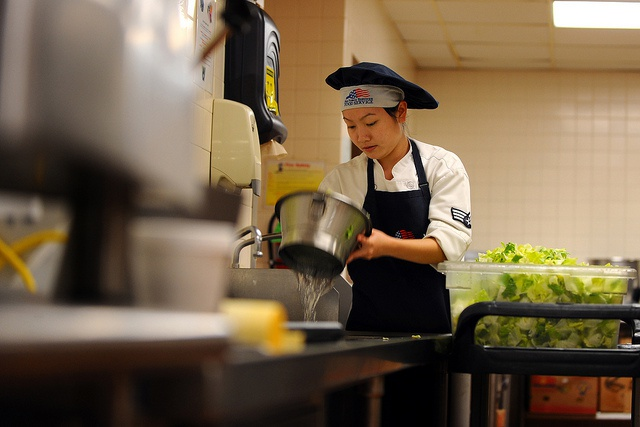Describe the objects in this image and their specific colors. I can see people in black, ivory, brown, and tan tones, cup in black, tan, and gray tones, bowl in black, olive, and gray tones, and sink in black and gray tones in this image. 